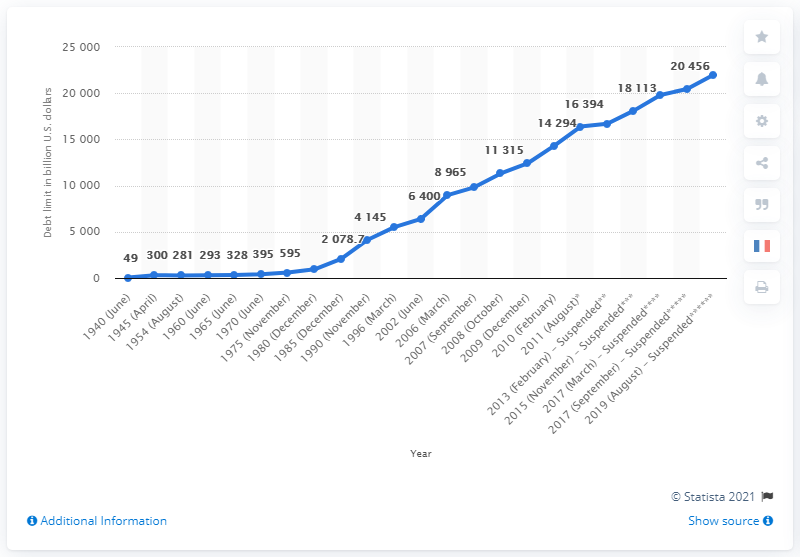Identify some key points in this picture. The debt limit was raised to $21,987.7... on August 2, 2019. 